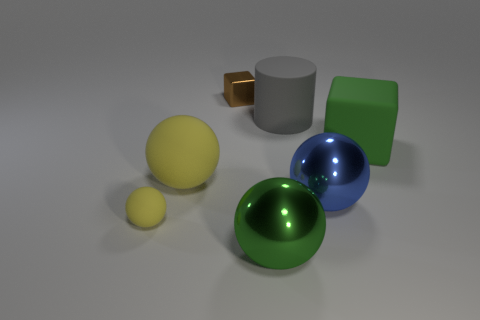Subtract all big matte spheres. How many spheres are left? 3 Add 1 green matte cubes. How many objects exist? 8 Subtract 3 spheres. How many spheres are left? 1 Subtract all blue balls. How many balls are left? 3 Subtract all blocks. Subtract all big cylinders. How many objects are left? 4 Add 4 small spheres. How many small spheres are left? 5 Add 5 big shiny balls. How many big shiny balls exist? 7 Subtract 0 yellow cubes. How many objects are left? 7 Subtract all cylinders. How many objects are left? 6 Subtract all blue cylinders. Subtract all blue cubes. How many cylinders are left? 1 